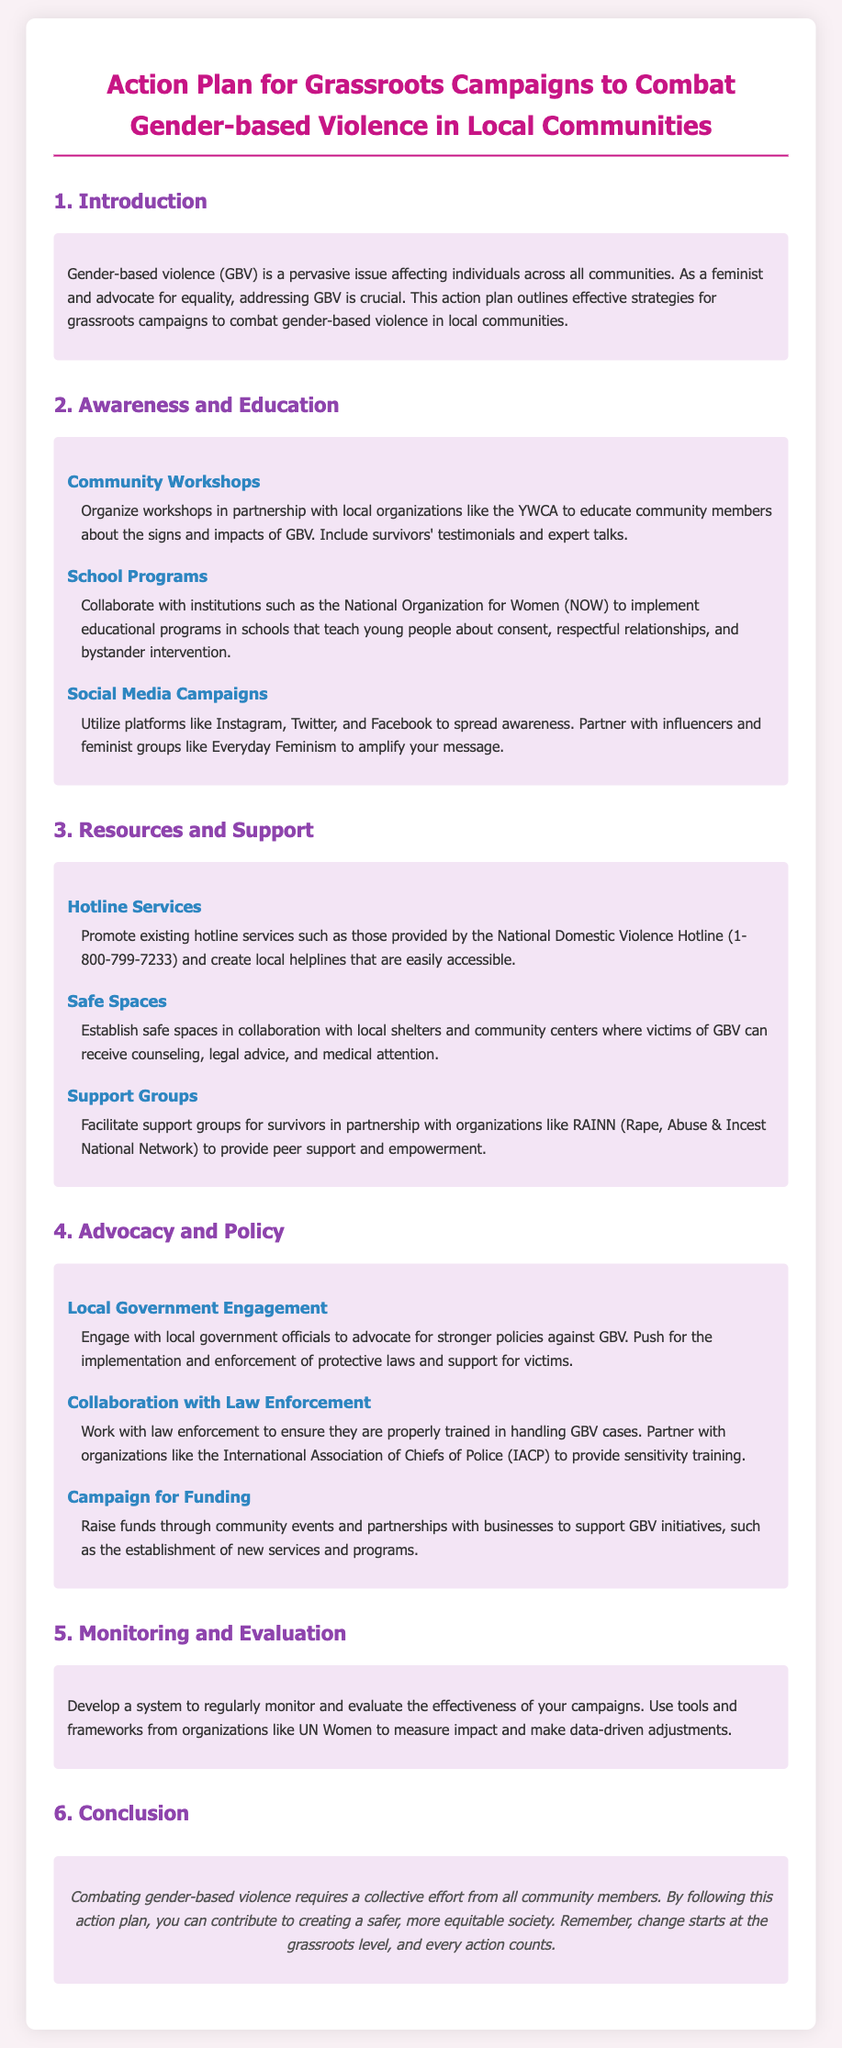What is the main issue addressed in the action plan? The action plan addresses the pervasive issue of gender-based violence (GBV) affecting individuals across all communities.
Answer: gender-based violence What organization is suggested for community workshops? The document mentions organizing workshops in partnership with local organizations such as the YWCA.
Answer: YWCA What hotline service is promoted in the document? The document promotes the National Domestic Violence Hotline as an essential resource for victims of GBV.
Answer: National Domestic Violence Hotline Which organization is mentioned for implementing school programs? The document states that collaboration with the National Organization for Women (NOW) is suggested for educational programs in schools.
Answer: National Organization for Women What type of training is suggested for law enforcement? The document recommends providing sensitivity training for law enforcement in handling GBV cases.
Answer: sensitivity training What is the purpose of establishing safe spaces? Safe spaces are established to provide victims of GBV with access to counseling, legal advice, and medical attention.
Answer: support for victims How should the effectiveness of campaigns be evaluated? The action plan suggests developing a system to regularly monitor and evaluate the effectiveness of campaigns using tools from organizations like UN Women.
Answer: data-driven adjustments What is a key strategy for raising funds for GBV initiatives? The document indicates that raising funds through community events and partnerships with businesses is a key strategy.
Answer: community events What is the overall goal of the action plan? The overall goal of the action plan is to contribute to creating a safer, more equitable society by combating gender-based violence.
Answer: safer, more equitable society 